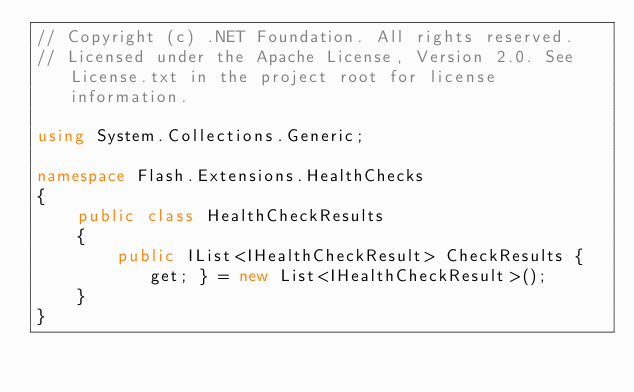<code> <loc_0><loc_0><loc_500><loc_500><_C#_>// Copyright (c) .NET Foundation. All rights reserved.
// Licensed under the Apache License, Version 2.0. See License.txt in the project root for license information.

using System.Collections.Generic;

namespace Flash.Extensions.HealthChecks
{
    public class HealthCheckResults
    {
        public IList<IHealthCheckResult> CheckResults { get; } = new List<IHealthCheckResult>();
    }
}
</code> 